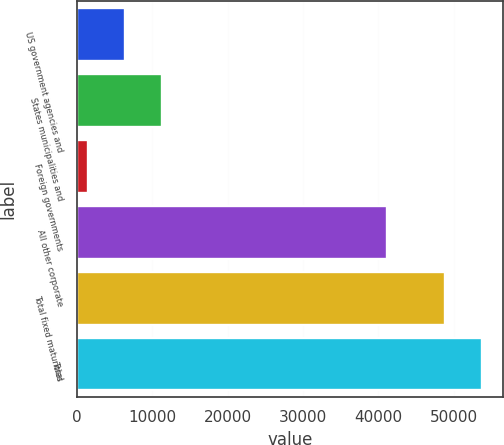Convert chart. <chart><loc_0><loc_0><loc_500><loc_500><bar_chart><fcel>US government agencies and<fcel>States municipalities and<fcel>Foreign governments<fcel>All other corporate<fcel>Total fixed maturities<fcel>Total<nl><fcel>6339.7<fcel>11252.4<fcel>1427<fcel>41198<fcel>48877<fcel>53789.7<nl></chart> 